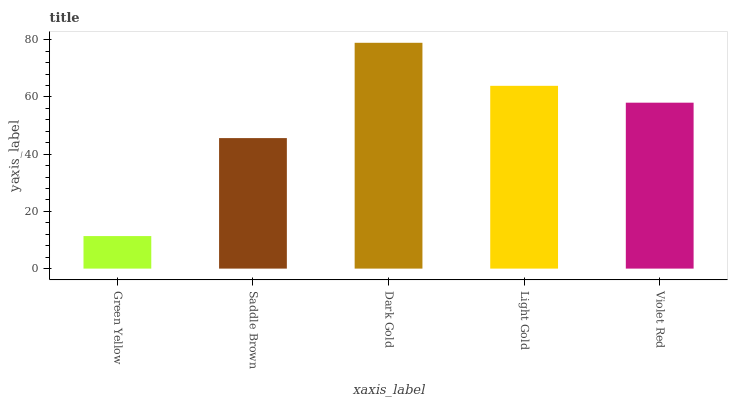Is Saddle Brown the minimum?
Answer yes or no. No. Is Saddle Brown the maximum?
Answer yes or no. No. Is Saddle Brown greater than Green Yellow?
Answer yes or no. Yes. Is Green Yellow less than Saddle Brown?
Answer yes or no. Yes. Is Green Yellow greater than Saddle Brown?
Answer yes or no. No. Is Saddle Brown less than Green Yellow?
Answer yes or no. No. Is Violet Red the high median?
Answer yes or no. Yes. Is Violet Red the low median?
Answer yes or no. Yes. Is Dark Gold the high median?
Answer yes or no. No. Is Green Yellow the low median?
Answer yes or no. No. 